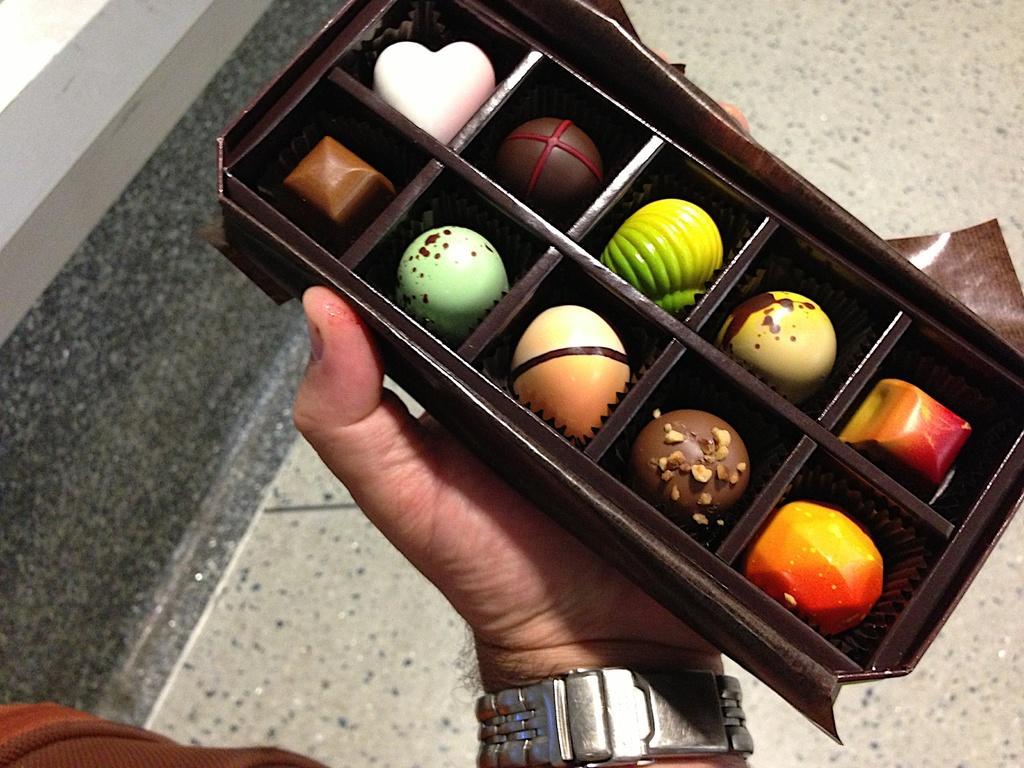In one or two sentences, can you explain what this image depicts? In this picture we can see the round chocolates in the brown tray, holding in the person hand. Behind we can see the flooring tile. 